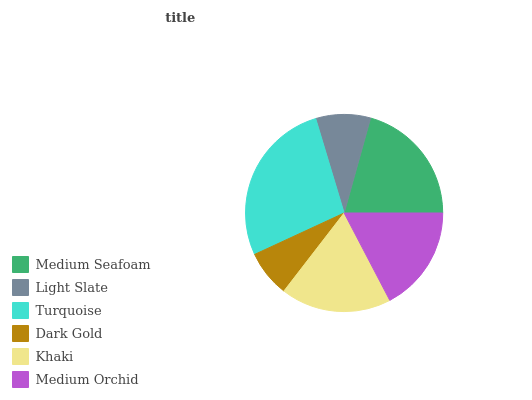Is Dark Gold the minimum?
Answer yes or no. Yes. Is Turquoise the maximum?
Answer yes or no. Yes. Is Light Slate the minimum?
Answer yes or no. No. Is Light Slate the maximum?
Answer yes or no. No. Is Medium Seafoam greater than Light Slate?
Answer yes or no. Yes. Is Light Slate less than Medium Seafoam?
Answer yes or no. Yes. Is Light Slate greater than Medium Seafoam?
Answer yes or no. No. Is Medium Seafoam less than Light Slate?
Answer yes or no. No. Is Khaki the high median?
Answer yes or no. Yes. Is Medium Orchid the low median?
Answer yes or no. Yes. Is Turquoise the high median?
Answer yes or no. No. Is Khaki the low median?
Answer yes or no. No. 